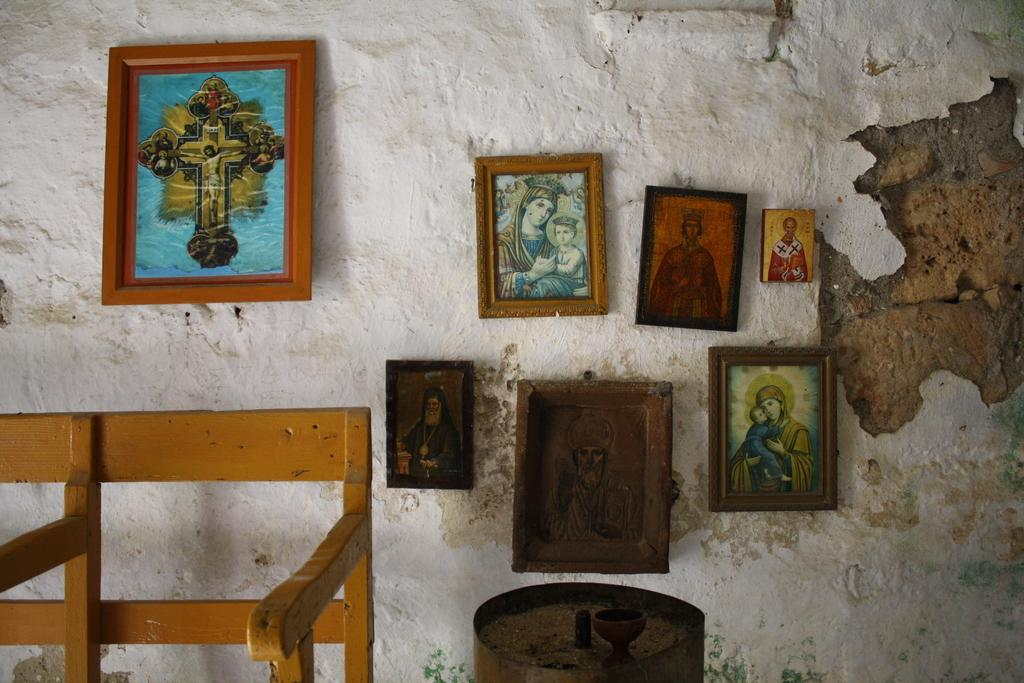What type of seating is present in the image? There is a bench in the image. What other object can be seen in the image? There is an object in the image, but its specific nature is not mentioned in the facts. What is attached to the wall in the image? There are frames attached to the wall in the image. What suggestion is being made by the women in the image? There is no mention of women in the image, so it is not possible to answer a question about their suggestions. What type of toe is visible in the image? There is no toe present in the image. 